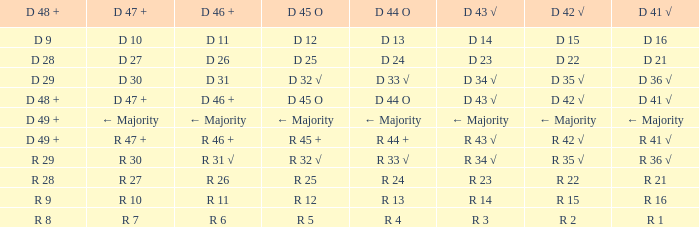What is the value of D 45 O, when the value of D 41 √ is r 41 √? R 45 +. 